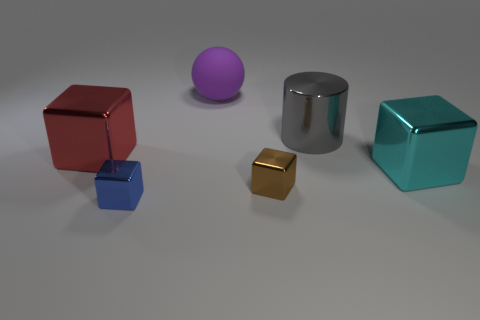Subtract 2 blocks. How many blocks are left? 2 Subtract all green cubes. Subtract all gray spheres. How many cubes are left? 4 Add 3 gray matte blocks. How many objects exist? 9 Subtract all cylinders. How many objects are left? 5 Subtract all large red metallic cylinders. Subtract all small blue cubes. How many objects are left? 5 Add 2 gray metallic things. How many gray metallic things are left? 3 Add 5 big cyan shiny things. How many big cyan shiny things exist? 6 Subtract 0 brown cylinders. How many objects are left? 6 